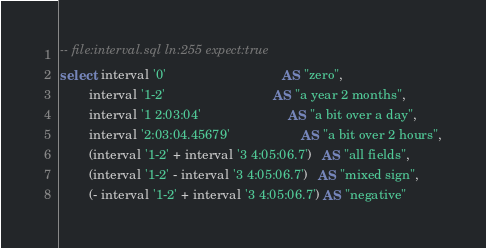Convert code to text. <code><loc_0><loc_0><loc_500><loc_500><_SQL_>-- file:interval.sql ln:255 expect:true
select  interval '0'                                AS "zero",
        interval '1-2'                              AS "a year 2 months",
        interval '1 2:03:04'                        AS "a bit over a day",
        interval '2:03:04.45679'                    AS "a bit over 2 hours",
        (interval '1-2' + interval '3 4:05:06.7')   AS "all fields",
        (interval '1-2' - interval '3 4:05:06.7')   AS "mixed sign",
        (- interval '1-2' + interval '3 4:05:06.7') AS "negative"
</code> 